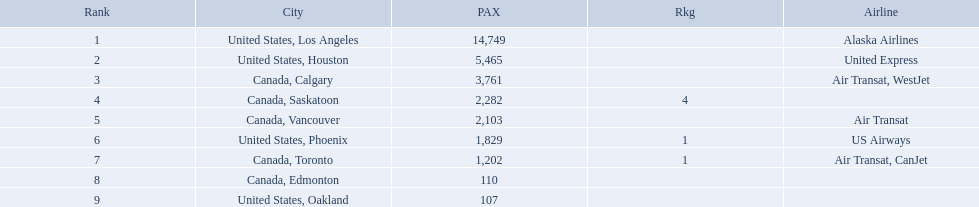Could you help me parse every detail presented in this table? {'header': ['Rank', 'City', 'PAX', 'Rkg', 'Airline'], 'rows': [['1', 'United States, Los Angeles', '14,749', '', 'Alaska Airlines'], ['2', 'United States, Houston', '5,465', '', 'United Express'], ['3', 'Canada, Calgary', '3,761', '', 'Air Transat, WestJet'], ['4', 'Canada, Saskatoon', '2,282', '4', ''], ['5', 'Canada, Vancouver', '2,103', '', 'Air Transat'], ['6', 'United States, Phoenix', '1,829', '1', 'US Airways'], ['7', 'Canada, Toronto', '1,202', '1', 'Air Transat, CanJet'], ['8', 'Canada, Edmonton', '110', '', ''], ['9', 'United States, Oakland', '107', '', '']]} Where are the destinations of the airport? United States, Los Angeles, United States, Houston, Canada, Calgary, Canada, Saskatoon, Canada, Vancouver, United States, Phoenix, Canada, Toronto, Canada, Edmonton, United States, Oakland. What is the number of passengers to phoenix? 1,829. 